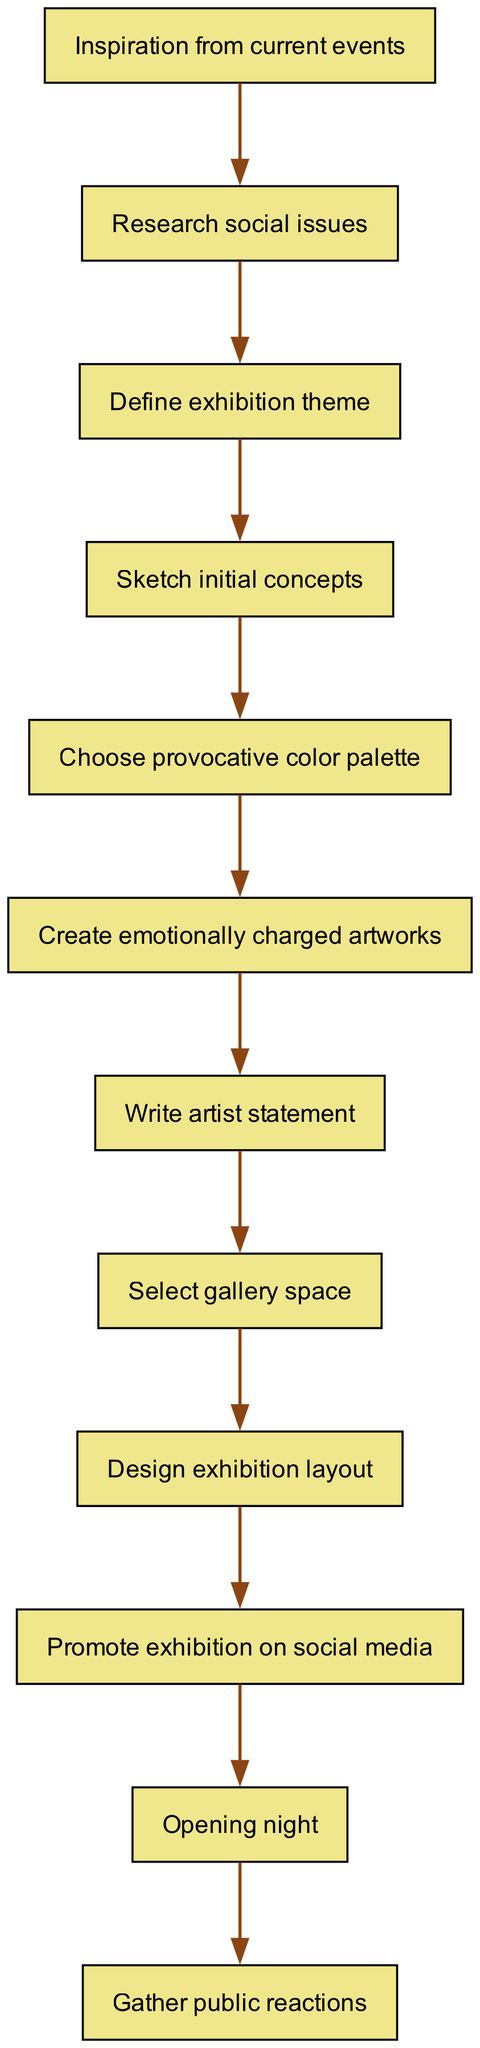What is the first step in the process? The first step is "Inspiration from current events," as it is the initial node with no incoming edges, indicating it starts the process.
Answer: Inspiration from current events How many nodes are present in the diagram? By counting all the unique steps listed in the nodes section, there are a total of twelve distinct nodes representing different steps in the process.
Answer: 12 What follows "Define exhibition theme"? The next step that follows "Define exhibition theme" according to the directed edges is "Sketch initial concepts," indicating a direct progression from the theme definition to sketching.
Answer: Sketch initial concepts Which node comes before "Create emotionally charged artworks"? The node that precedes "Create emotionally charged artworks" is "Choose provocative color palette," demonstrating the sequence of selecting colors before creating the actual artworks.
Answer: Choose provocative color palette What is the final step in the process? The final step, indicated by the last node in the directed flow, is "Gather public reactions," showing the culmination of the exhibition process after the opening night.
Answer: Gather public reactions What is the relationship between "Select gallery space" and "Write artist statement"? There is a directed edge from "Write artist statement" to "Select gallery space," suggesting that the artist statement must be completed before choosing the gallery space for the exhibition.
Answer: Write artist statement → Select gallery space How many edges connect the nodes in the diagram? By reviewing the edges section, there are eleven edges connecting the nodes, representing the direct relationships and flow between the various steps in the process.
Answer: 11 What is the purpose of "Promote exhibition on social media"? "Promote exhibition on social media" functions as a step to generate interest and attract an audience before culminating in "Opening night," showing its role in preparing for the exhibition's launch.
Answer: Attract audience How are "Sketch initial concepts" and "Choose provocative color palette" connected? "Sketch initial concepts" is directly linked to "Choose provocative color palette" through an edge that indicates you need to visualize ideas before determining the color scheme used in the artworks.
Answer: They are connected directly through an edge 